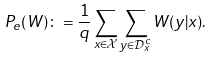<formula> <loc_0><loc_0><loc_500><loc_500>P _ { e } ( W ) \colon = \frac { 1 } { q } \sum _ { x \in \mathcal { X } } \sum _ { y \in \mathcal { D } _ { x } ^ { c } } W ( y | x ) .</formula> 